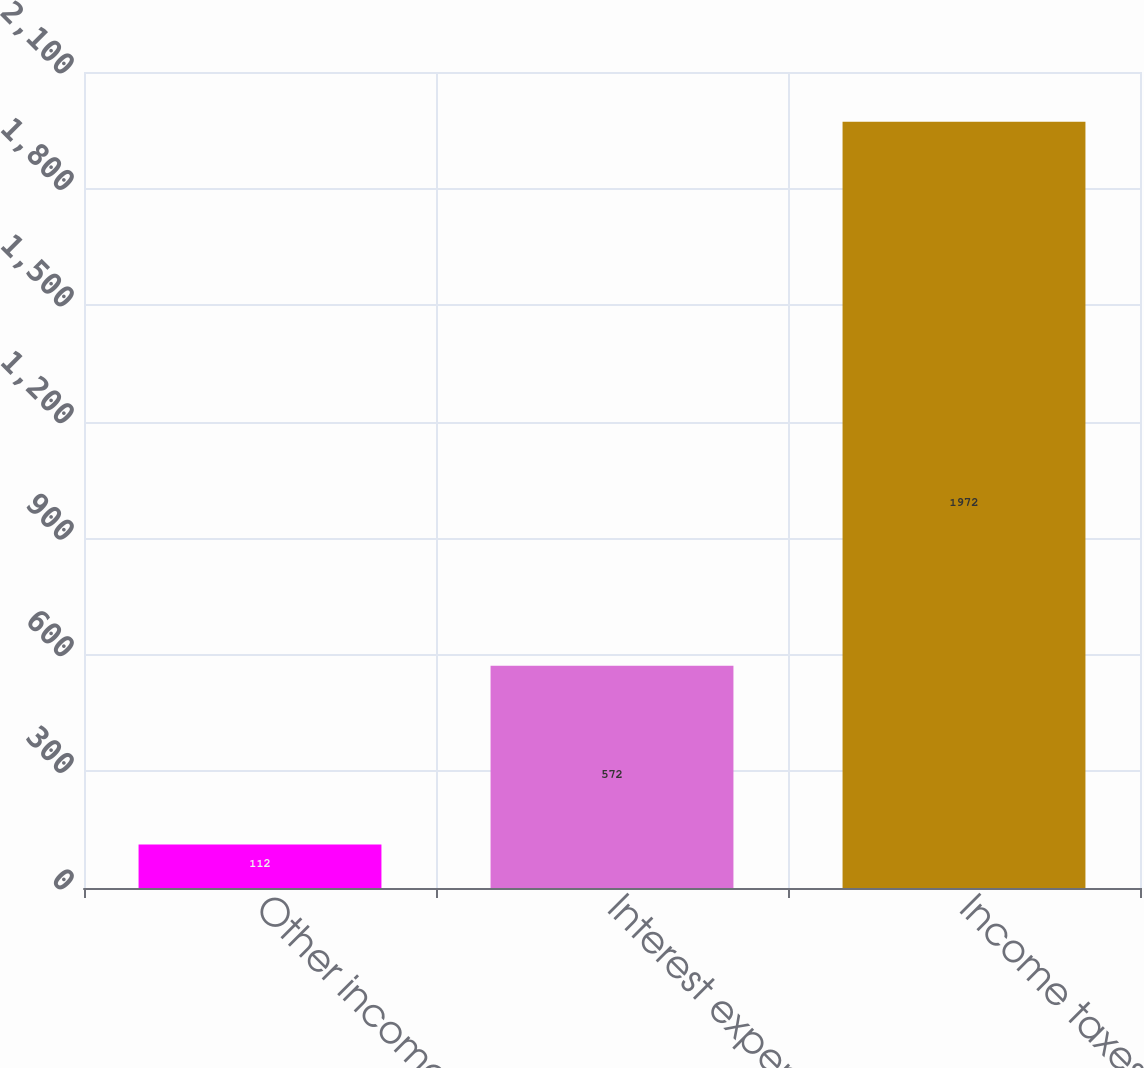Convert chart to OTSL. <chart><loc_0><loc_0><loc_500><loc_500><bar_chart><fcel>Other income<fcel>Interest expense<fcel>Income taxes<nl><fcel>112<fcel>572<fcel>1972<nl></chart> 